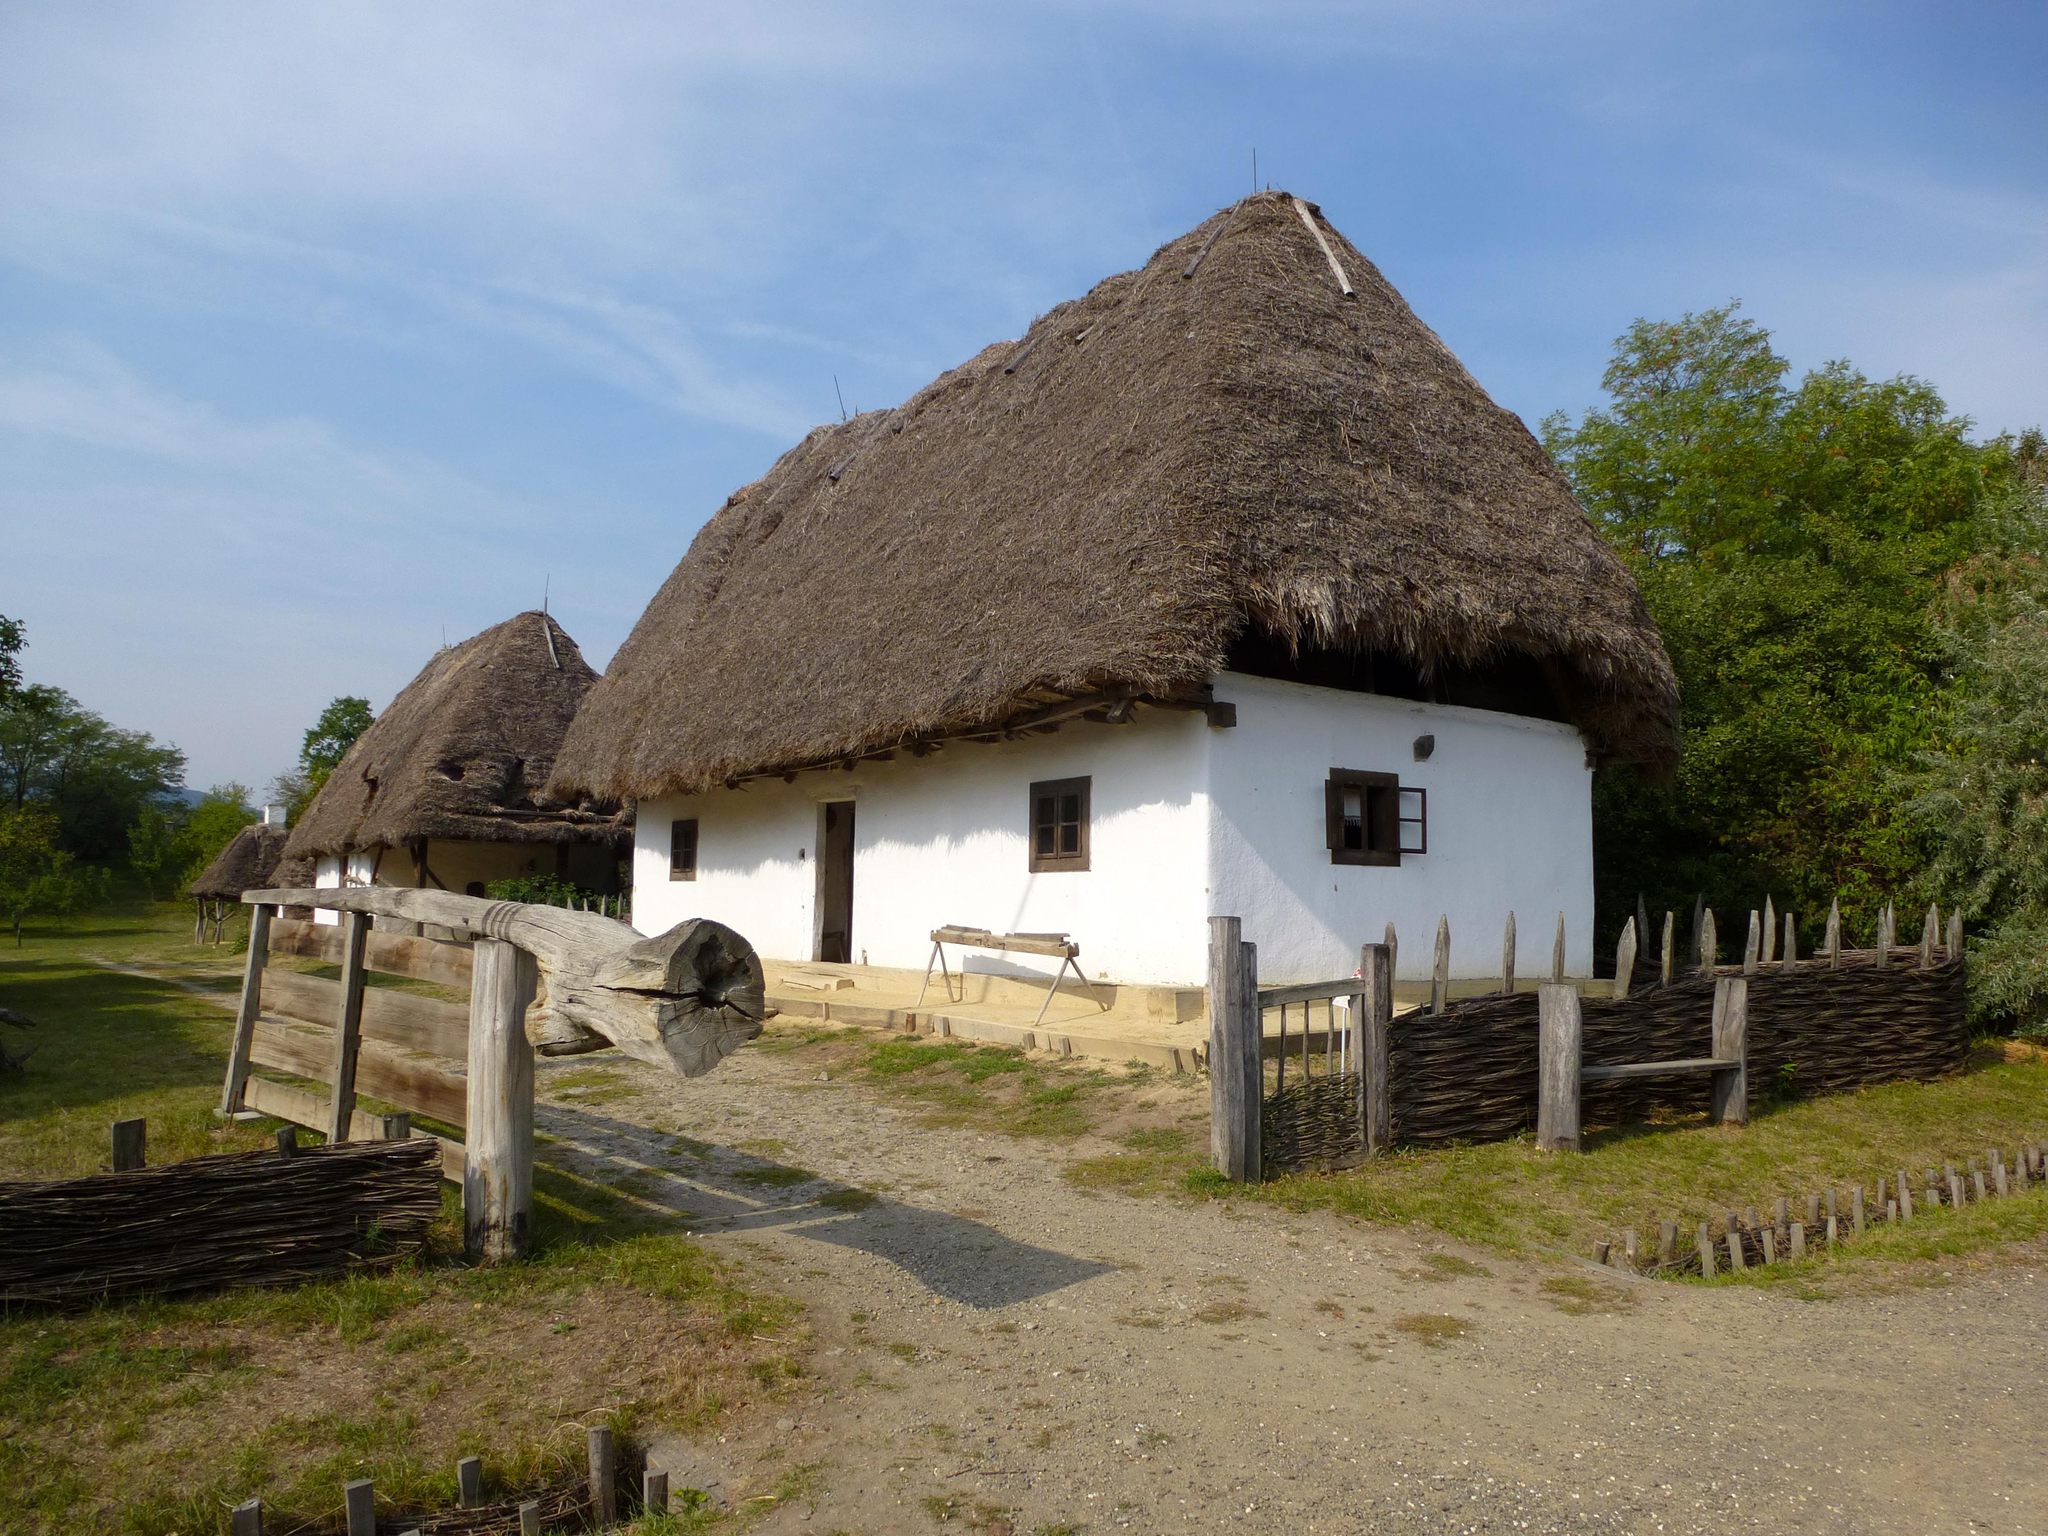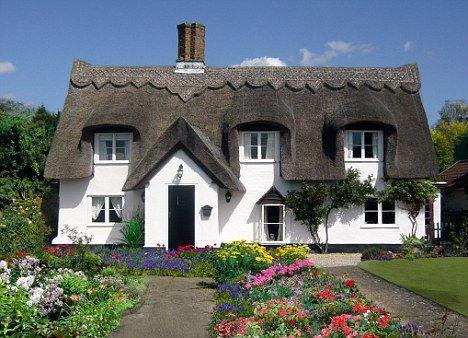The first image is the image on the left, the second image is the image on the right. Considering the images on both sides, is "One of the houses has two chimneys, one on each end of the roof line." valid? Answer yes or no. No. The first image is the image on the left, the second image is the image on the right. Examine the images to the left and right. Is the description "At least one of the 2 houses has a wooden fence around it." accurate? Answer yes or no. Yes. 